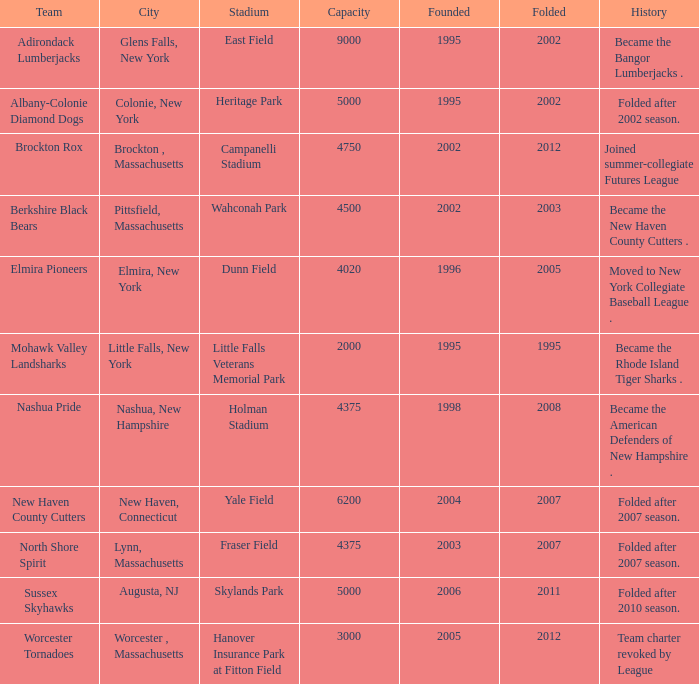For the team based at fraser field, what is their greatest folded value? 2007.0. 